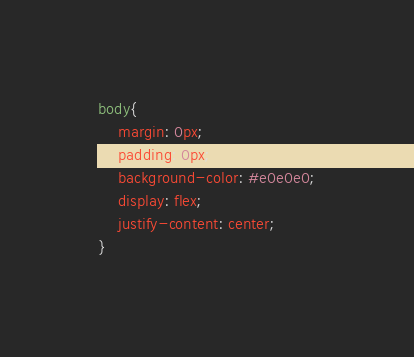Convert code to text. <code><loc_0><loc_0><loc_500><loc_500><_CSS_>body{
    margin: 0px;
    padding: 0px;
    background-color: #e0e0e0;
    display: flex;
    justify-content: center;
}
</code> 